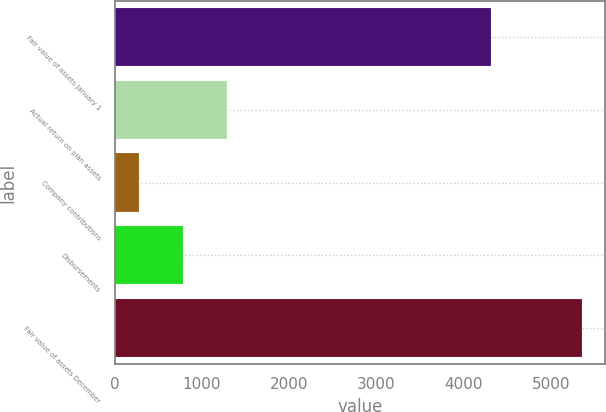<chart> <loc_0><loc_0><loc_500><loc_500><bar_chart><fcel>Fair value of assets January 1<fcel>Actual return on plan assets<fcel>Company contributions<fcel>Disbursements<fcel>Fair value of assets December<nl><fcel>4319<fcel>1291.4<fcel>275<fcel>783.2<fcel>5357<nl></chart> 